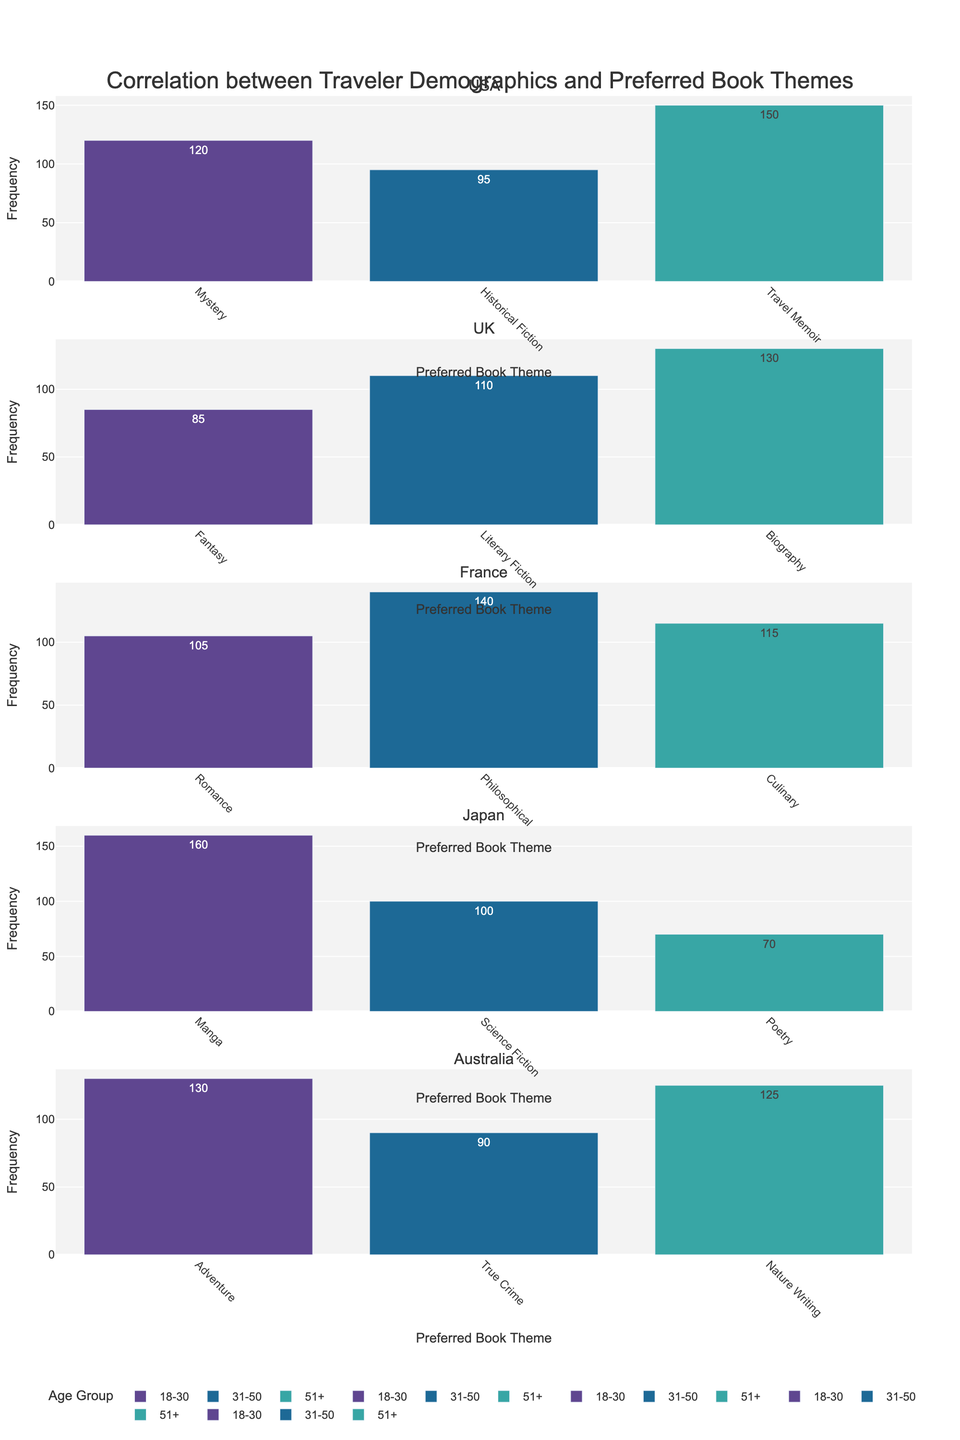What's the most preferred book theme among travelers aged 18-30 in Japan? Look at the bar heights for the 18-30 age group in the Japan subplot. Manga has the highest frequency.
Answer: Manga Which country shows the highest frequency for the 'Mystery' book theme? Compare the bar heights for 'Mystery' book themes across all subplots. The USA shows the highest frequency for 'Mystery'.
Answer: USA Comparing travelers aged 51+ in Australia and Japan, which group has a higher preference for their respective top book themes? In the Australia subplot, the 51+ age group shows a preference with a high bar for 'Nature Writing'. In Japan, the preference for 'Poetry' is lower. Therefore, Australia's 51+ age group has a higher preference.
Answer: Australia In the UK, which age group shows the highest preference for 'Literary Fiction'? Look at the UK subplot and compare the bars for 'Literary Fiction' across different age groups. The 31-50 age group has the highest bar.
Answer: 31-50 How does the preference for 'Historical Fiction' in the USA compare between the 18-30 and 31-50 age groups? Compare the bars for 'Historical Fiction' in the USA subplot between the 18-30 and 31-50 age groups. The 31-50 age group has a higher preference.
Answer: The 31-50 age group has a higher preference Which age group in France has the highest preference for 'Philosophical' books? In the France subplot, look at the bars for 'Philosophical' books across different age groups. The 31-50 age group has the highest bar.
Answer: 31-50 What is the average preference frequency for 'Travel Memoir' in the USA across all age groups? In the USA subplot, the bar for 'Travel Memoir' is visible only for the 51+ age group, with a frequency of 150. So, the average is 150/1 = 150.
Answer: 150 Between the age groups of 18-30 and 51+ in France, which group shows a higher preference for 'Romance'? Compare the bars for 'Romance' in the France subplot between the 18-30 and 51+ age groups. The 18-30 age group has a higher preference.
Answer: 18-30 In Japan, how does the preference for 'Science Fiction' in the 31-50 age group compare to 'Manga' in the 18-30 age group? Compare the bars for 'Science Fiction' in the 31-50 age group to 'Manga' in the 18-30 age group in the Japan subplot. 'Manga' (160) is higher than 'Science Fiction' (100).
Answer: 'Manga' has a higher preference What is the most preferred book theme in Australia for travelers aged 18-30? Look at the Australia subplot and identify the tallest bar for the 18-30 age group. The highest bar is for 'Adventure'.
Answer: Adventure 